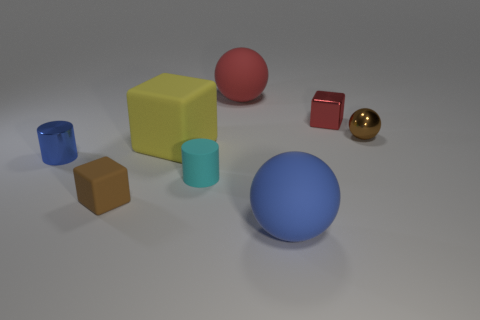What material is the big thing that is the same color as the shiny block?
Your answer should be very brief. Rubber. Is the color of the big sphere that is in front of the small brown shiny ball the same as the metallic object that is in front of the brown metallic ball?
Offer a very short reply. Yes. Is the number of small matte blocks in front of the large blue sphere greater than the number of tiny cyan rubber objects right of the tiny red block?
Give a very brief answer. No. The other tiny object that is the same shape as the tiny blue metallic object is what color?
Make the answer very short. Cyan. Does the small blue metallic object have the same shape as the blue thing that is in front of the tiny shiny cylinder?
Your answer should be compact. No. What number of other objects are there of the same material as the large blue sphere?
Offer a very short reply. 4. Do the metal sphere and the small rubber thing behind the small brown rubber thing have the same color?
Provide a short and direct response. No. There is a large sphere that is behind the rubber cylinder; what is it made of?
Keep it short and to the point. Rubber. Are there any tiny cylinders that have the same color as the metallic ball?
Your answer should be very brief. No. What is the color of the rubber block that is the same size as the blue cylinder?
Make the answer very short. Brown. 